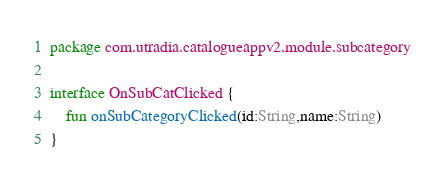<code> <loc_0><loc_0><loc_500><loc_500><_Kotlin_>package com.utradia.catalogueappv2.module.subcategory

interface OnSubCatClicked {
    fun onSubCategoryClicked(id:String,name:String)
}</code> 